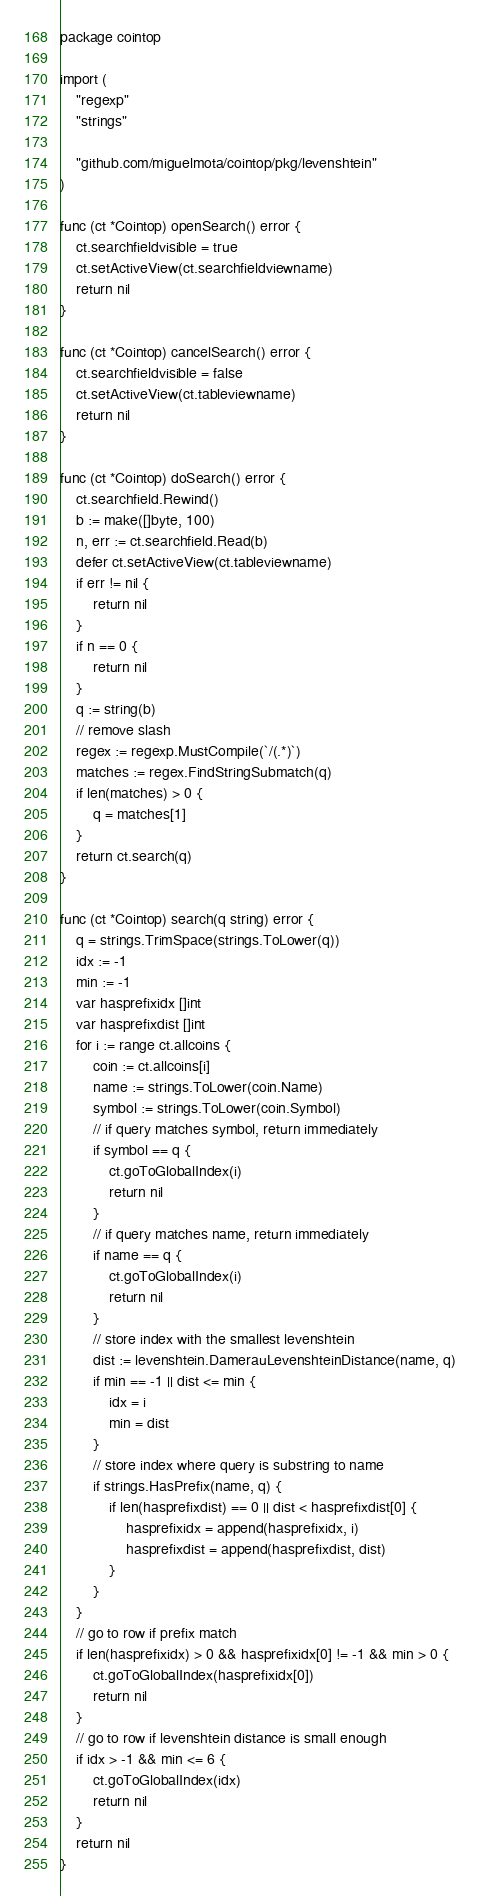Convert code to text. <code><loc_0><loc_0><loc_500><loc_500><_Go_>package cointop

import (
	"regexp"
	"strings"

	"github.com/miguelmota/cointop/pkg/levenshtein"
)

func (ct *Cointop) openSearch() error {
	ct.searchfieldvisible = true
	ct.setActiveView(ct.searchfieldviewname)
	return nil
}

func (ct *Cointop) cancelSearch() error {
	ct.searchfieldvisible = false
	ct.setActiveView(ct.tableviewname)
	return nil
}

func (ct *Cointop) doSearch() error {
	ct.searchfield.Rewind()
	b := make([]byte, 100)
	n, err := ct.searchfield.Read(b)
	defer ct.setActiveView(ct.tableviewname)
	if err != nil {
		return nil
	}
	if n == 0 {
		return nil
	}
	q := string(b)
	// remove slash
	regex := regexp.MustCompile(`/(.*)`)
	matches := regex.FindStringSubmatch(q)
	if len(matches) > 0 {
		q = matches[1]
	}
	return ct.search(q)
}

func (ct *Cointop) search(q string) error {
	q = strings.TrimSpace(strings.ToLower(q))
	idx := -1
	min := -1
	var hasprefixidx []int
	var hasprefixdist []int
	for i := range ct.allcoins {
		coin := ct.allcoins[i]
		name := strings.ToLower(coin.Name)
		symbol := strings.ToLower(coin.Symbol)
		// if query matches symbol, return immediately
		if symbol == q {
			ct.goToGlobalIndex(i)
			return nil
		}
		// if query matches name, return immediately
		if name == q {
			ct.goToGlobalIndex(i)
			return nil
		}
		// store index with the smallest levenshtein
		dist := levenshtein.DamerauLevenshteinDistance(name, q)
		if min == -1 || dist <= min {
			idx = i
			min = dist
		}
		// store index where query is substring to name
		if strings.HasPrefix(name, q) {
			if len(hasprefixdist) == 0 || dist < hasprefixdist[0] {
				hasprefixidx = append(hasprefixidx, i)
				hasprefixdist = append(hasprefixdist, dist)
			}
		}
	}
	// go to row if prefix match
	if len(hasprefixidx) > 0 && hasprefixidx[0] != -1 && min > 0 {
		ct.goToGlobalIndex(hasprefixidx[0])
		return nil
	}
	// go to row if levenshtein distance is small enough
	if idx > -1 && min <= 6 {
		ct.goToGlobalIndex(idx)
		return nil
	}
	return nil
}
</code> 